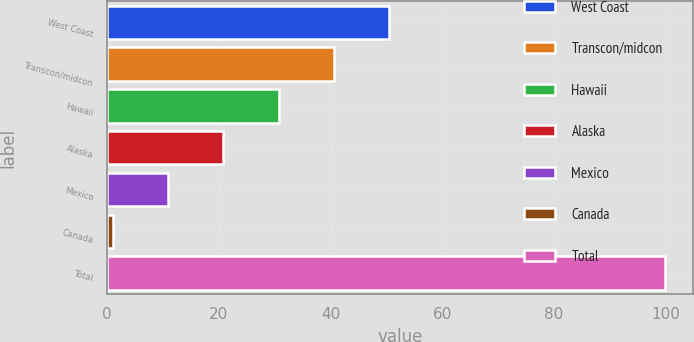<chart> <loc_0><loc_0><loc_500><loc_500><bar_chart><fcel>West Coast<fcel>Transcon/midcon<fcel>Hawaii<fcel>Alaska<fcel>Mexico<fcel>Canada<fcel>Total<nl><fcel>50.5<fcel>40.6<fcel>30.7<fcel>20.8<fcel>10.9<fcel>1<fcel>100<nl></chart> 